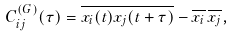<formula> <loc_0><loc_0><loc_500><loc_500>C ^ { ( G ) } _ { i j } ( \tau ) = \overline { x _ { i } ( t ) x _ { j } ( t + \tau ) } - \overline { x _ { i } } \, \overline { x _ { j } } ,</formula> 